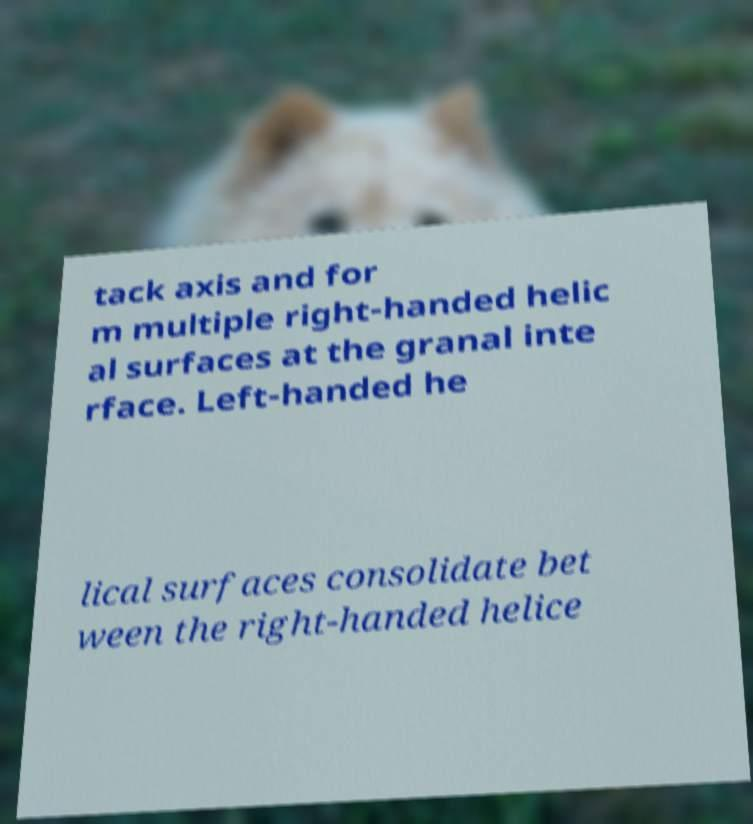Can you accurately transcribe the text from the provided image for me? tack axis and for m multiple right-handed helic al surfaces at the granal inte rface. Left-handed he lical surfaces consolidate bet ween the right-handed helice 